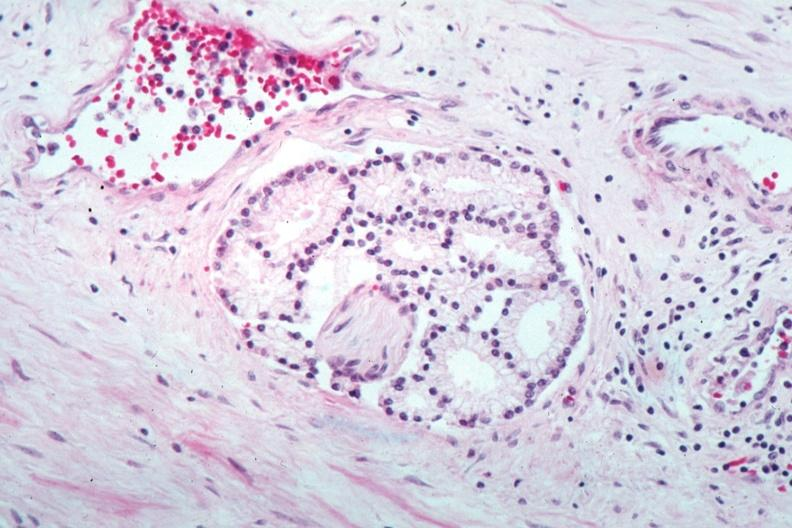what does this image show?
Answer the question using a single word or phrase. Perineural invasion by a well differentiated adenocarcinoma 